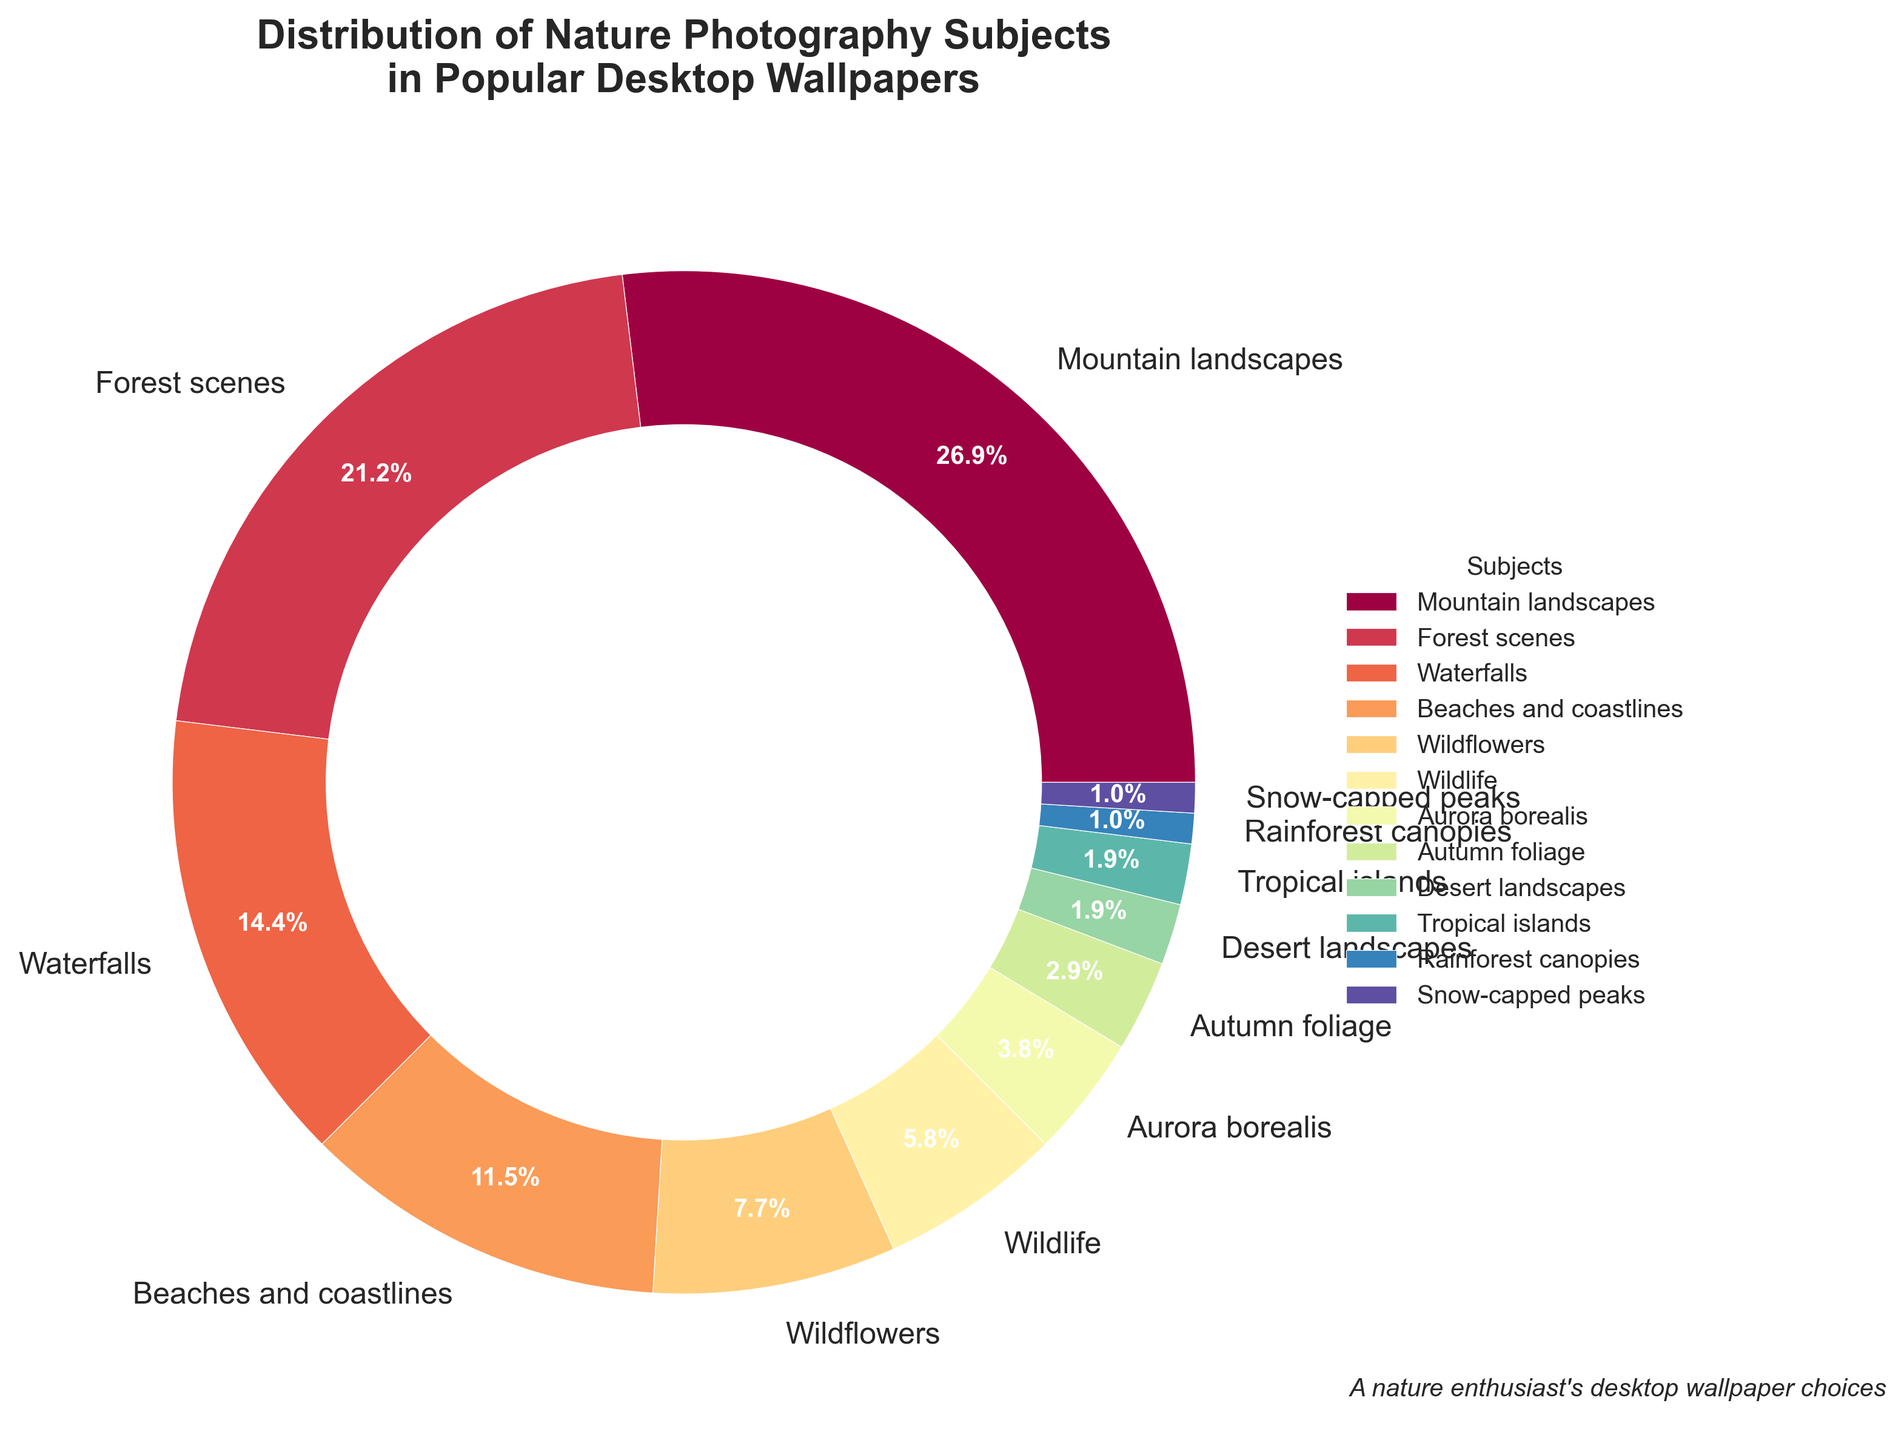What is the most common subject in popular desktop wallpapers? The pie chart shows the percentages of different nature photography subjects in desktop wallpapers. The segment labeled "Mountain landscapes" has the highest percentage.
Answer: Mountain landscapes Which subject has the smallest percentage and how much is it? By examining the pie chart, we see the smallest slice corresponds to "Snow-capped peaks" with a percentage label of 1%.
Answer: Snow-capped peaks, 1% How much more popular are "Mountain landscapes" compared to "Aurora borealis"? "Mountain landscapes" have a percentage of 28%, while "Aurora borealis" is 4%. The difference is 28% - 4%.
Answer: 24% What is the combined percentage of "Waterfalls" and "Beaches and coastlines"? The pie chart shows "Waterfalls" at 15% and "Beaches and coastlines" at 12%. Summing these gives 15% + 12%.
Answer: 27% Compare the popularity of "Forest scenes" to "Wildflowers." Which is more popular and by how much? "Forest scenes" is 22% and "Wildflowers" is 8%. "Forest scenes" is more popular by 22% - 8%.
Answer: Forest scenes, 14% What is the total percentage share of subjects with less than 5%? The subjects with less than 5% are "Aurora borealis" (4%), "Autumn foliage" (3%), "Desert landscapes" (2%), "Tropical islands" (2%), "Rainforest canopies" (1%), and "Snow-capped peaks" (1%). Summing these gives 4% + 3% + 2% + 2% + 1% + 1%.
Answer: 13% Which subjects are represented by the brightest colors on the pie chart? The pie chart uses bright colors from the Spectral colormap. Observing the bright segments, they correspond to "Mountain landscapes," "Forest scenes," and "Waterfalls."
Answer: Mountain landscapes, Forest scenes, Waterfalls How much do "Forest scenes," "Wildflowers," and "Wildlife" together account for? The pie chart shows "Forest scenes" is 22%, "Wildflowers" is 8%, and "Wildlife" is 6%. Summing these gives 22% + 8% + 6%.
Answer: 36% What is the difference in percentage between "Beaches and coastlines" and "Winter" scenes (combining "Snow-capped peaks" and "Aurora borealis")? "Beaches and coastlines" is 12%, "Snow-capped peaks" is 1%, and "Aurora borealis" is 4%. The combined winter scenes are 1% + 4% = 5%. The difference is 12% - 5%.
Answer: 7% Which subject is depicted in the center on the right of the pie chart's legend? The legend is ordered sequentially around the pie chart. The center subject on the right side of the legend is "Wildflowers."
Answer: Wildflowers 